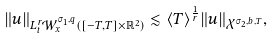Convert formula to latex. <formula><loc_0><loc_0><loc_500><loc_500>\| u \| _ { L _ { t } ^ { r } \mathcal { W } _ { x } ^ { \sigma _ { 1 } , q } ( [ - T , T ] \times \mathbb { R } ^ { 2 } ) } \lesssim \langle T \rangle ^ { \frac { 1 } { r } } \| u \| _ { \mathcal { X } ^ { \sigma _ { 2 } , b , T } } ,</formula> 